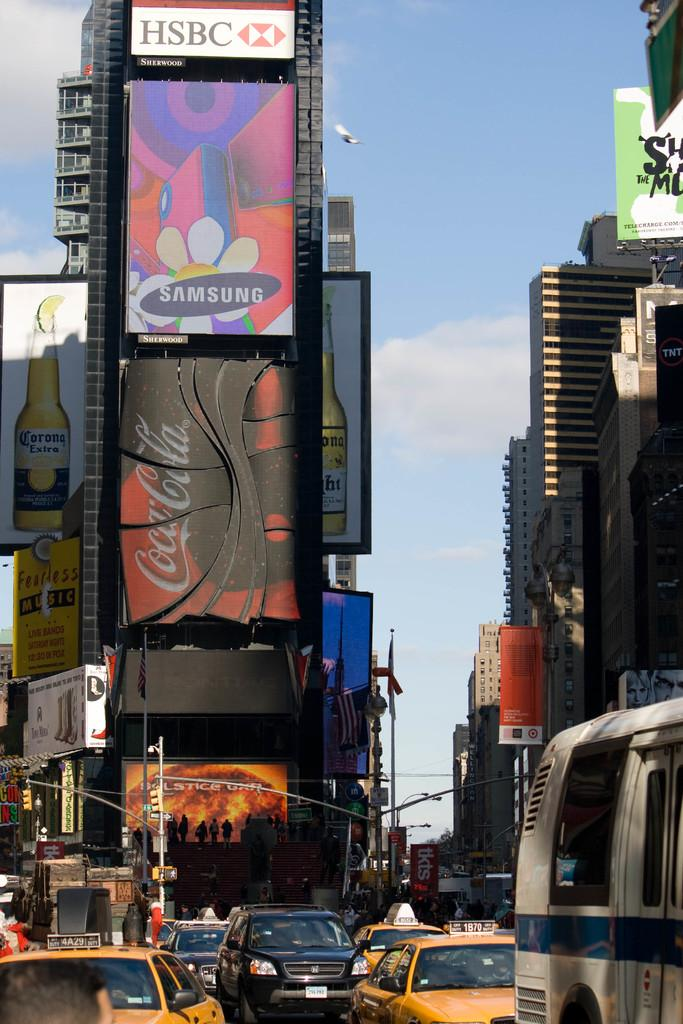Provide a one-sentence caption for the provided image. crowded street and digital billboards for such companies as samsung and coca-cola. 